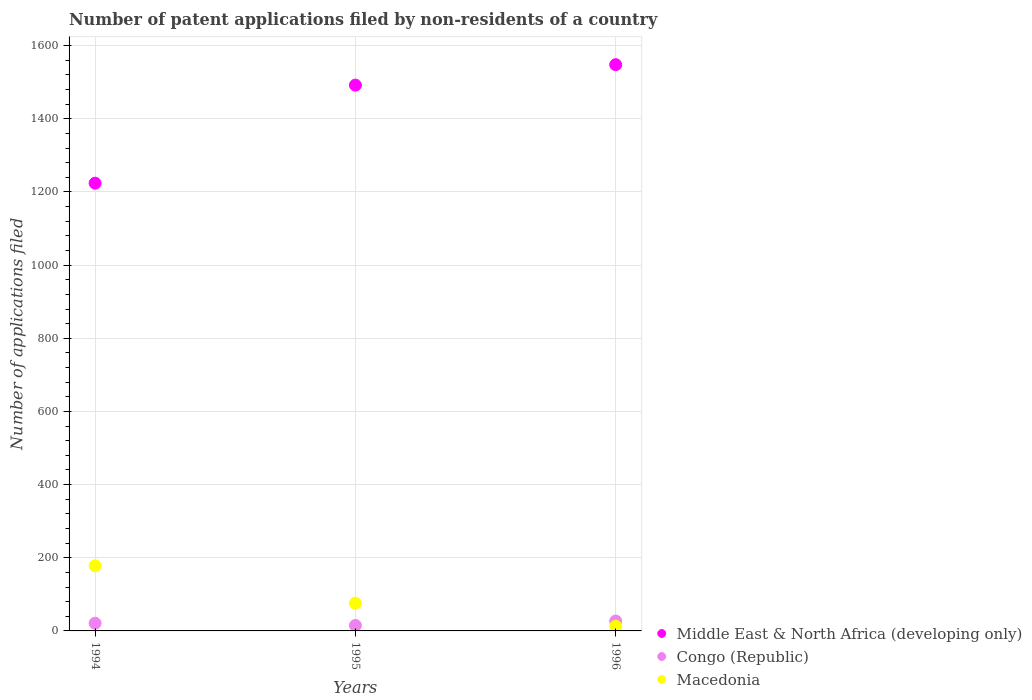How many different coloured dotlines are there?
Make the answer very short. 3. What is the number of applications filed in Macedonia in 1996?
Your answer should be very brief. 13. What is the average number of applications filed in Middle East & North Africa (developing only) per year?
Your answer should be very brief. 1421.33. In the year 1996, what is the difference between the number of applications filed in Macedonia and number of applications filed in Middle East & North Africa (developing only)?
Ensure brevity in your answer.  -1535. What is the ratio of the number of applications filed in Congo (Republic) in 1994 to that in 1995?
Make the answer very short. 1.4. What is the difference between the highest and the second highest number of applications filed in Macedonia?
Your answer should be compact. 102. What is the difference between the highest and the lowest number of applications filed in Congo (Republic)?
Provide a short and direct response. 12. Is the sum of the number of applications filed in Congo (Republic) in 1994 and 1995 greater than the maximum number of applications filed in Macedonia across all years?
Provide a succinct answer. No. Is it the case that in every year, the sum of the number of applications filed in Congo (Republic) and number of applications filed in Middle East & North Africa (developing only)  is greater than the number of applications filed in Macedonia?
Provide a short and direct response. Yes. Does the number of applications filed in Congo (Republic) monotonically increase over the years?
Your answer should be compact. No. Is the number of applications filed in Congo (Republic) strictly less than the number of applications filed in Macedonia over the years?
Make the answer very short. No. How many dotlines are there?
Give a very brief answer. 3. Does the graph contain grids?
Make the answer very short. Yes. Where does the legend appear in the graph?
Keep it short and to the point. Bottom right. What is the title of the graph?
Offer a terse response. Number of patent applications filed by non-residents of a country. What is the label or title of the Y-axis?
Your answer should be compact. Number of applications filed. What is the Number of applications filed in Middle East & North Africa (developing only) in 1994?
Offer a very short reply. 1224. What is the Number of applications filed of Congo (Republic) in 1994?
Make the answer very short. 21. What is the Number of applications filed of Macedonia in 1994?
Your response must be concise. 178. What is the Number of applications filed of Middle East & North Africa (developing only) in 1995?
Give a very brief answer. 1492. What is the Number of applications filed in Middle East & North Africa (developing only) in 1996?
Your answer should be very brief. 1548. What is the Number of applications filed in Congo (Republic) in 1996?
Your answer should be compact. 27. What is the Number of applications filed of Macedonia in 1996?
Make the answer very short. 13. Across all years, what is the maximum Number of applications filed of Middle East & North Africa (developing only)?
Provide a short and direct response. 1548. Across all years, what is the maximum Number of applications filed of Macedonia?
Give a very brief answer. 178. Across all years, what is the minimum Number of applications filed in Middle East & North Africa (developing only)?
Ensure brevity in your answer.  1224. Across all years, what is the minimum Number of applications filed of Macedonia?
Offer a terse response. 13. What is the total Number of applications filed of Middle East & North Africa (developing only) in the graph?
Offer a terse response. 4264. What is the total Number of applications filed in Congo (Republic) in the graph?
Offer a terse response. 63. What is the total Number of applications filed of Macedonia in the graph?
Your answer should be very brief. 267. What is the difference between the Number of applications filed in Middle East & North Africa (developing only) in 1994 and that in 1995?
Offer a very short reply. -268. What is the difference between the Number of applications filed of Congo (Republic) in 1994 and that in 1995?
Make the answer very short. 6. What is the difference between the Number of applications filed of Macedonia in 1994 and that in 1995?
Your response must be concise. 102. What is the difference between the Number of applications filed in Middle East & North Africa (developing only) in 1994 and that in 1996?
Provide a succinct answer. -324. What is the difference between the Number of applications filed of Macedonia in 1994 and that in 1996?
Your answer should be very brief. 165. What is the difference between the Number of applications filed of Middle East & North Africa (developing only) in 1995 and that in 1996?
Offer a terse response. -56. What is the difference between the Number of applications filed of Congo (Republic) in 1995 and that in 1996?
Give a very brief answer. -12. What is the difference between the Number of applications filed in Macedonia in 1995 and that in 1996?
Ensure brevity in your answer.  63. What is the difference between the Number of applications filed of Middle East & North Africa (developing only) in 1994 and the Number of applications filed of Congo (Republic) in 1995?
Provide a short and direct response. 1209. What is the difference between the Number of applications filed of Middle East & North Africa (developing only) in 1994 and the Number of applications filed of Macedonia in 1995?
Make the answer very short. 1148. What is the difference between the Number of applications filed in Congo (Republic) in 1994 and the Number of applications filed in Macedonia in 1995?
Offer a terse response. -55. What is the difference between the Number of applications filed of Middle East & North Africa (developing only) in 1994 and the Number of applications filed of Congo (Republic) in 1996?
Keep it short and to the point. 1197. What is the difference between the Number of applications filed in Middle East & North Africa (developing only) in 1994 and the Number of applications filed in Macedonia in 1996?
Provide a short and direct response. 1211. What is the difference between the Number of applications filed in Middle East & North Africa (developing only) in 1995 and the Number of applications filed in Congo (Republic) in 1996?
Ensure brevity in your answer.  1465. What is the difference between the Number of applications filed of Middle East & North Africa (developing only) in 1995 and the Number of applications filed of Macedonia in 1996?
Offer a terse response. 1479. What is the difference between the Number of applications filed in Congo (Republic) in 1995 and the Number of applications filed in Macedonia in 1996?
Offer a terse response. 2. What is the average Number of applications filed of Middle East & North Africa (developing only) per year?
Make the answer very short. 1421.33. What is the average Number of applications filed of Congo (Republic) per year?
Provide a succinct answer. 21. What is the average Number of applications filed of Macedonia per year?
Your answer should be very brief. 89. In the year 1994, what is the difference between the Number of applications filed in Middle East & North Africa (developing only) and Number of applications filed in Congo (Republic)?
Ensure brevity in your answer.  1203. In the year 1994, what is the difference between the Number of applications filed of Middle East & North Africa (developing only) and Number of applications filed of Macedonia?
Keep it short and to the point. 1046. In the year 1994, what is the difference between the Number of applications filed of Congo (Republic) and Number of applications filed of Macedonia?
Offer a very short reply. -157. In the year 1995, what is the difference between the Number of applications filed in Middle East & North Africa (developing only) and Number of applications filed in Congo (Republic)?
Your answer should be compact. 1477. In the year 1995, what is the difference between the Number of applications filed of Middle East & North Africa (developing only) and Number of applications filed of Macedonia?
Offer a very short reply. 1416. In the year 1995, what is the difference between the Number of applications filed in Congo (Republic) and Number of applications filed in Macedonia?
Your answer should be very brief. -61. In the year 1996, what is the difference between the Number of applications filed of Middle East & North Africa (developing only) and Number of applications filed of Congo (Republic)?
Ensure brevity in your answer.  1521. In the year 1996, what is the difference between the Number of applications filed in Middle East & North Africa (developing only) and Number of applications filed in Macedonia?
Make the answer very short. 1535. What is the ratio of the Number of applications filed of Middle East & North Africa (developing only) in 1994 to that in 1995?
Give a very brief answer. 0.82. What is the ratio of the Number of applications filed of Congo (Republic) in 1994 to that in 1995?
Your response must be concise. 1.4. What is the ratio of the Number of applications filed in Macedonia in 1994 to that in 1995?
Your answer should be compact. 2.34. What is the ratio of the Number of applications filed of Middle East & North Africa (developing only) in 1994 to that in 1996?
Ensure brevity in your answer.  0.79. What is the ratio of the Number of applications filed of Macedonia in 1994 to that in 1996?
Keep it short and to the point. 13.69. What is the ratio of the Number of applications filed of Middle East & North Africa (developing only) in 1995 to that in 1996?
Offer a very short reply. 0.96. What is the ratio of the Number of applications filed of Congo (Republic) in 1995 to that in 1996?
Give a very brief answer. 0.56. What is the ratio of the Number of applications filed in Macedonia in 1995 to that in 1996?
Offer a terse response. 5.85. What is the difference between the highest and the second highest Number of applications filed in Middle East & North Africa (developing only)?
Keep it short and to the point. 56. What is the difference between the highest and the second highest Number of applications filed of Macedonia?
Provide a short and direct response. 102. What is the difference between the highest and the lowest Number of applications filed in Middle East & North Africa (developing only)?
Provide a succinct answer. 324. What is the difference between the highest and the lowest Number of applications filed in Congo (Republic)?
Your answer should be very brief. 12. What is the difference between the highest and the lowest Number of applications filed of Macedonia?
Offer a terse response. 165. 